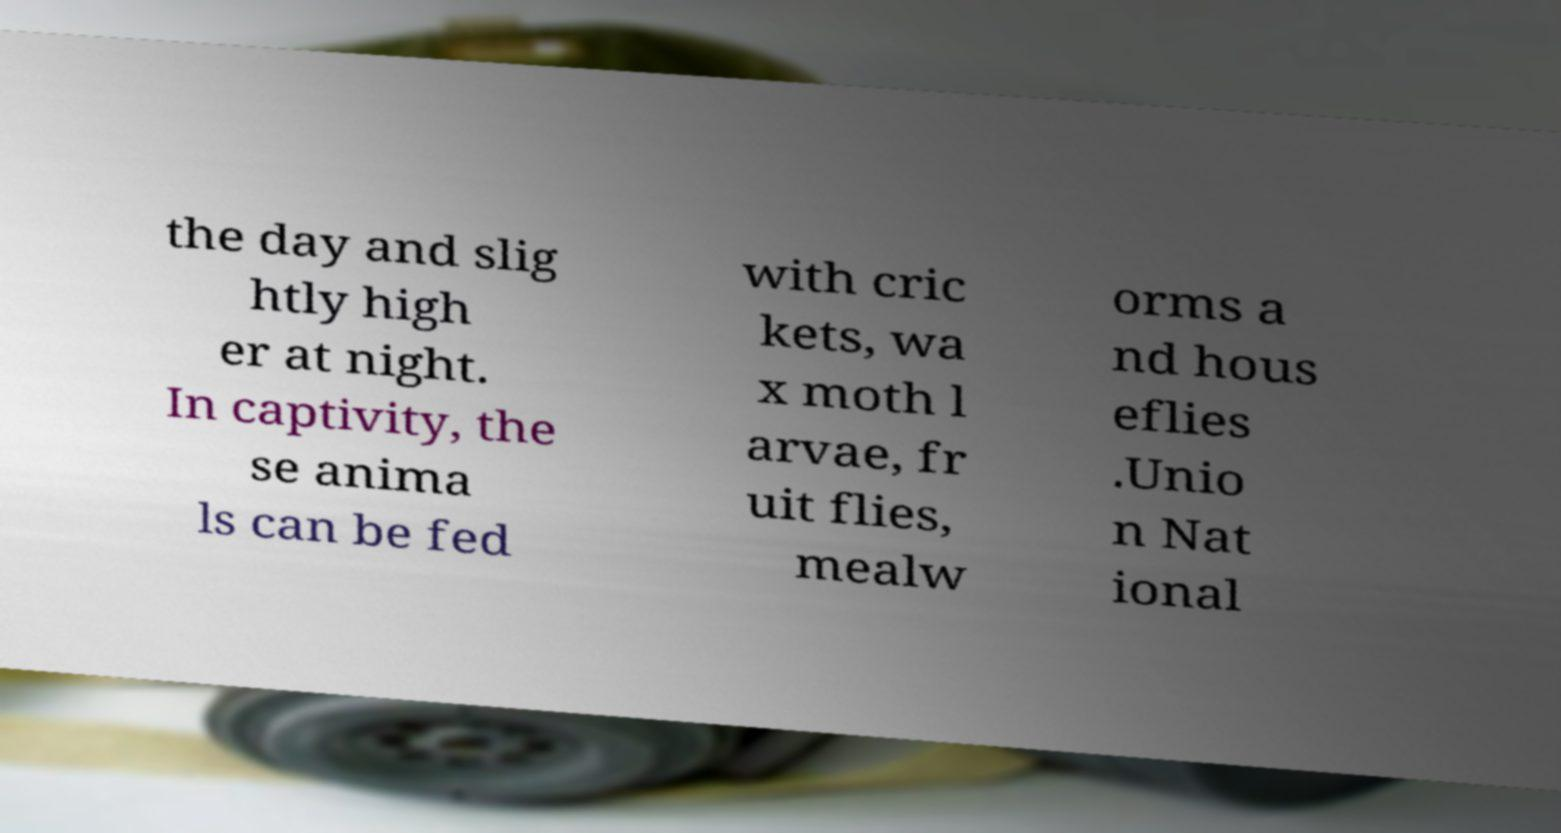I need the written content from this picture converted into text. Can you do that? the day and slig htly high er at night. In captivity, the se anima ls can be fed with cric kets, wa x moth l arvae, fr uit flies, mealw orms a nd hous eflies .Unio n Nat ional 